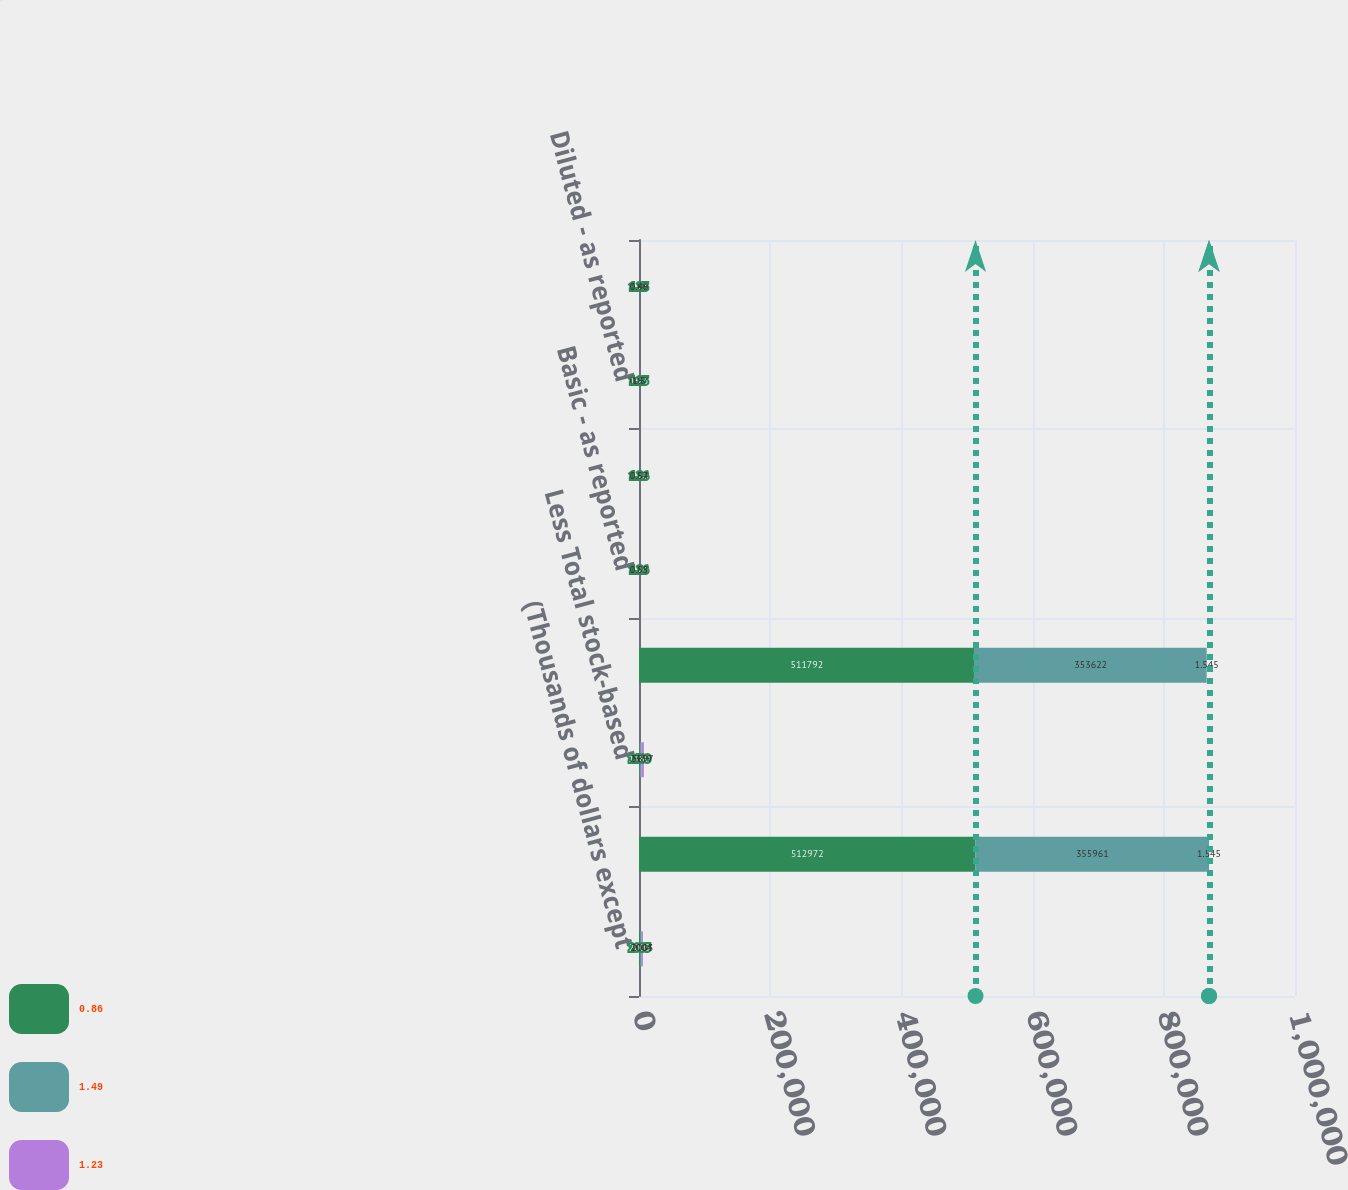<chart> <loc_0><loc_0><loc_500><loc_500><stacked_bar_chart><ecel><fcel>(Thousands of dollars except<fcel>Net income - as reported<fcel>Less Total stock-based<fcel>Pro forma net income (loss)<fcel>Basic - as reported<fcel>Basic - pro forma<fcel>Diluted - as reported<fcel>Diluted - pro forma<nl><fcel>0.86<fcel>2005<fcel>512972<fcel>1180<fcel>511792<fcel>1.26<fcel>1.26<fcel>1.23<fcel>1.23<nl><fcel>1.49<fcel>2004<fcel>355961<fcel>2339<fcel>353622<fcel>0.88<fcel>0.87<fcel>0.87<fcel>0.86<nl><fcel>1.23<fcel>2003<fcel>1.545<fcel>3897<fcel>1.545<fcel>1.55<fcel>1.54<fcel>1.5<fcel>1.49<nl></chart> 